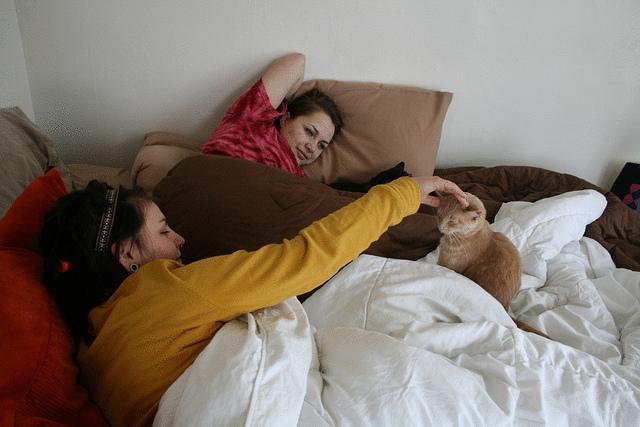What color is the pillow?
Short answer required. Brown. How many people are in the bed?
Quick response, please. 2. Are these animals often nicknamed the name of a favorite edible?
Keep it brief. No. Which girl wears a headband?
Be succinct. Yellow shirt. What is the woman wearing on her wrist?
Keep it brief. Nothing. What animal is the person touching?
Quick response, please. Cat. What color is the cat?
Give a very brief answer. Orange. 